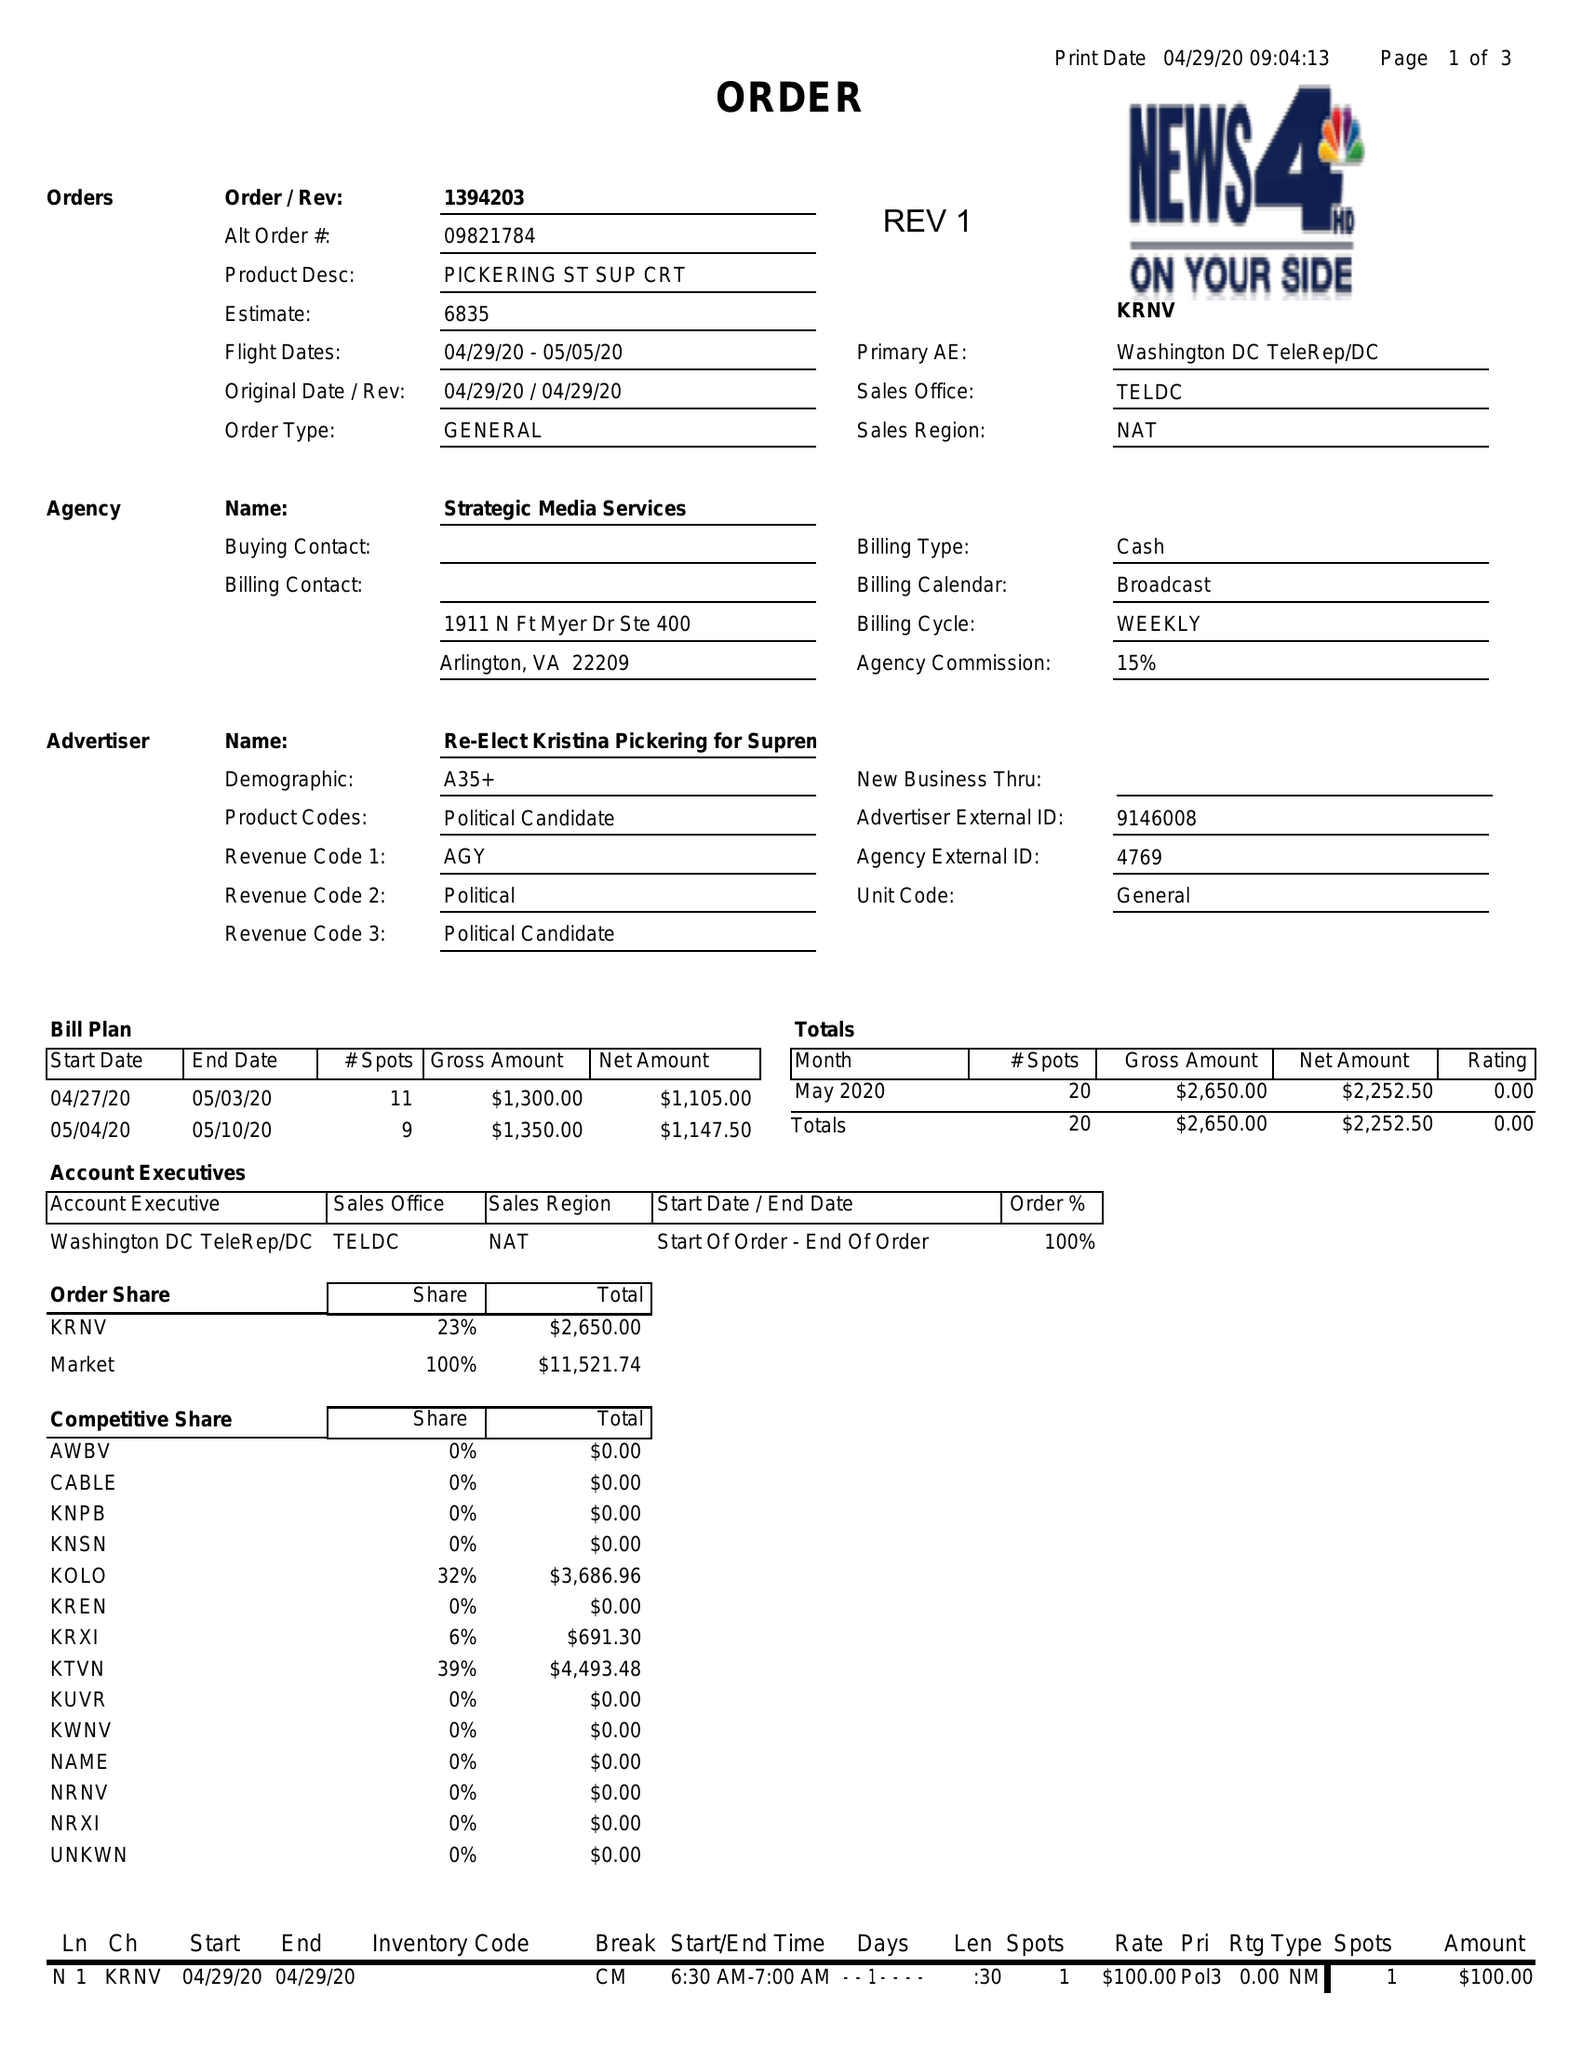What is the value for the gross_amount?
Answer the question using a single word or phrase. 2650.00 